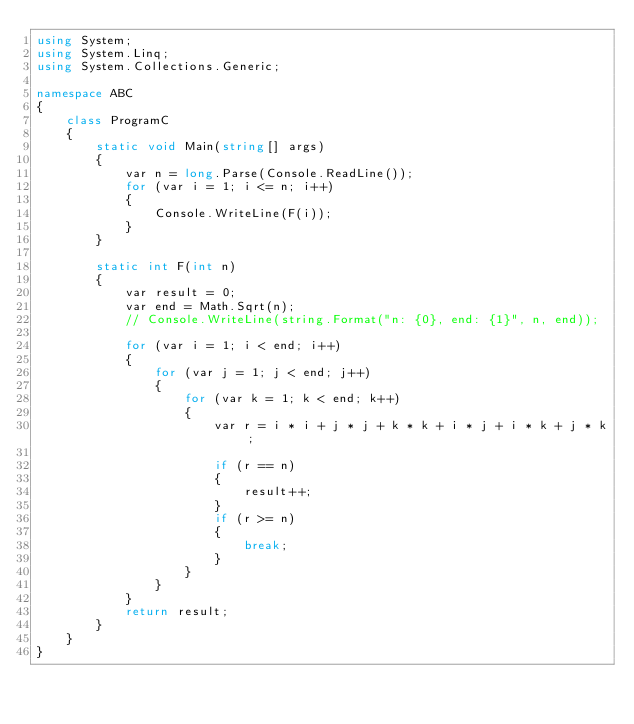Convert code to text. <code><loc_0><loc_0><loc_500><loc_500><_C#_>using System;
using System.Linq;
using System.Collections.Generic;

namespace ABC
{
    class ProgramC
    {
        static void Main(string[] args)
        {
            var n = long.Parse(Console.ReadLine());
            for (var i = 1; i <= n; i++)
            {
                Console.WriteLine(F(i));
            }
        }

        static int F(int n)
        {
            var result = 0;
            var end = Math.Sqrt(n);
            // Console.WriteLine(string.Format("n: {0}, end: {1}", n, end));

            for (var i = 1; i < end; i++)
            {
                for (var j = 1; j < end; j++)
                {
                    for (var k = 1; k < end; k++)
                    {
                        var r = i * i + j * j + k * k + i * j + i * k + j * k;

                        if (r == n)
                        {
                            result++;
                        }
                        if (r >= n)
                        {
                            break;
                        }
                    }
                }
            }
            return result;
        }
    }
}
</code> 